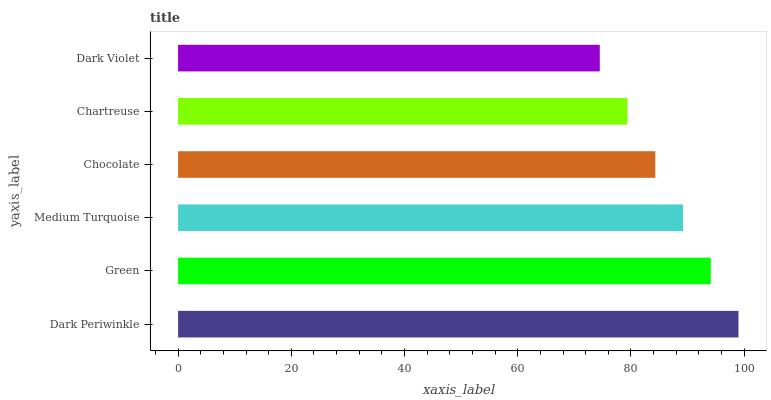Is Dark Violet the minimum?
Answer yes or no. Yes. Is Dark Periwinkle the maximum?
Answer yes or no. Yes. Is Green the minimum?
Answer yes or no. No. Is Green the maximum?
Answer yes or no. No. Is Dark Periwinkle greater than Green?
Answer yes or no. Yes. Is Green less than Dark Periwinkle?
Answer yes or no. Yes. Is Green greater than Dark Periwinkle?
Answer yes or no. No. Is Dark Periwinkle less than Green?
Answer yes or no. No. Is Medium Turquoise the high median?
Answer yes or no. Yes. Is Chocolate the low median?
Answer yes or no. Yes. Is Dark Violet the high median?
Answer yes or no. No. Is Green the low median?
Answer yes or no. No. 